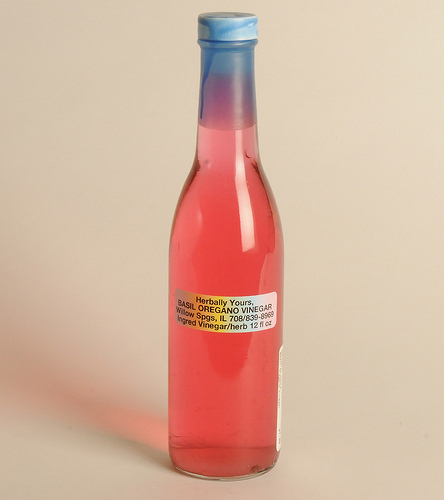<image>
Is the label above the floor? Yes. The label is positioned above the floor in the vertical space, higher up in the scene. 